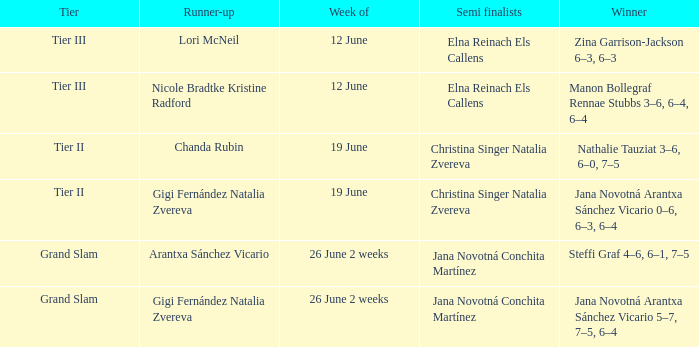Give me the full table as a dictionary. {'header': ['Tier', 'Runner-up', 'Week of', 'Semi finalists', 'Winner'], 'rows': [['Tier III', 'Lori McNeil', '12 June', 'Elna Reinach Els Callens', 'Zina Garrison-Jackson 6–3, 6–3'], ['Tier III', 'Nicole Bradtke Kristine Radford', '12 June', 'Elna Reinach Els Callens', 'Manon Bollegraf Rennae Stubbs 3–6, 6–4, 6–4'], ['Tier II', 'Chanda Rubin', '19 June', 'Christina Singer Natalia Zvereva', 'Nathalie Tauziat 3–6, 6–0, 7–5'], ['Tier II', 'Gigi Fernández Natalia Zvereva', '19 June', 'Christina Singer Natalia Zvereva', 'Jana Novotná Arantxa Sánchez Vicario 0–6, 6–3, 6–4'], ['Grand Slam', 'Arantxa Sánchez Vicario', '26 June 2 weeks', 'Jana Novotná Conchita Martínez', 'Steffi Graf 4–6, 6–1, 7–5'], ['Grand Slam', 'Gigi Fernández Natalia Zvereva', '26 June 2 weeks', 'Jana Novotná Conchita Martínez', 'Jana Novotná Arantxa Sánchez Vicario 5–7, 7–5, 6–4']]} When the Tier is listed as tier iii, who is the Winner? Zina Garrison-Jackson 6–3, 6–3, Manon Bollegraf Rennae Stubbs 3–6, 6–4, 6–4. 